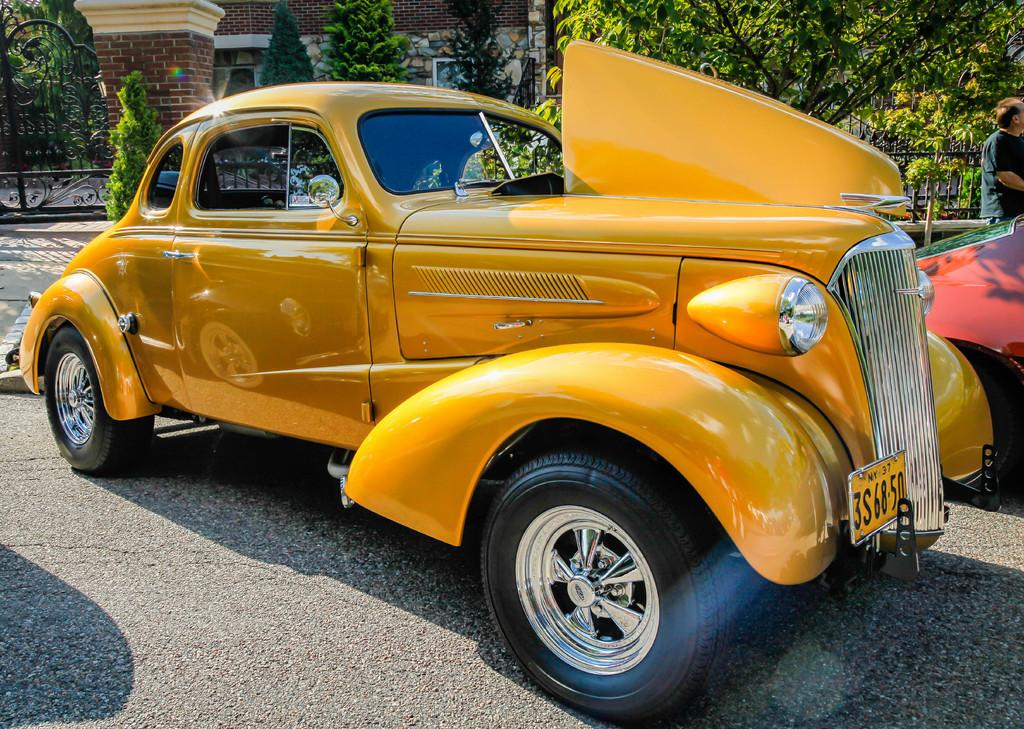What can be seen on the road in the image? There are cars on the road in the image. What is visible in the background of the image? There are trees, metal rods, and a house in the background of the image. Where is the man located in the image? The man is on the right side of the image. Can you see a cow walking on the road in the image? No, there is no cow present in the image. Are there any ghosts visible in the image? No, there are no ghosts present in the image. 